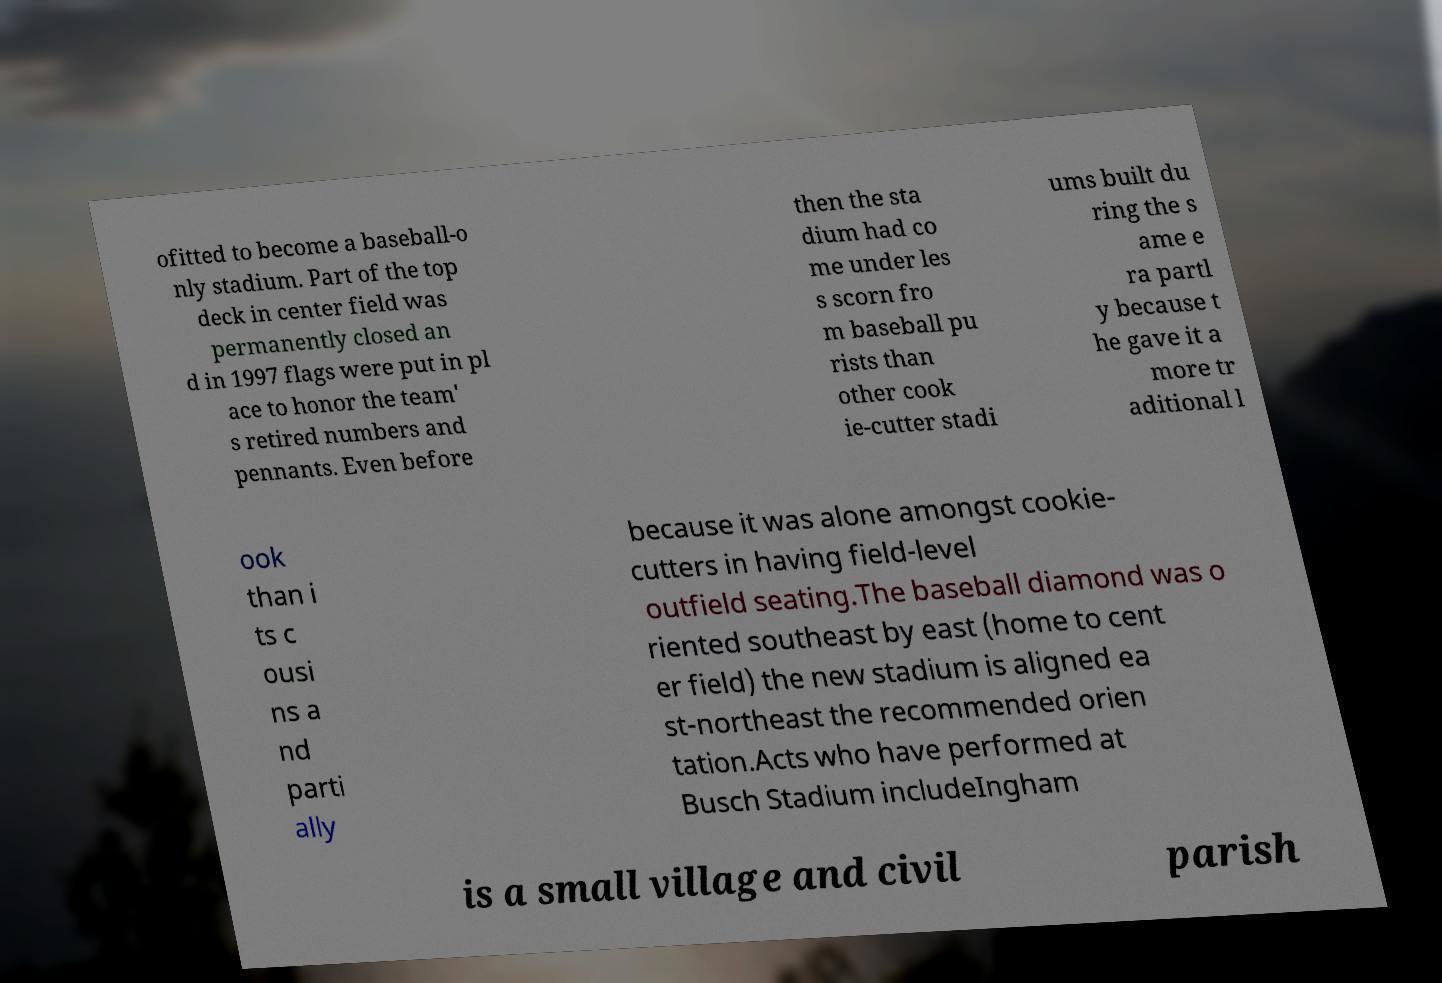What messages or text are displayed in this image? I need them in a readable, typed format. ofitted to become a baseball-o nly stadium. Part of the top deck in center field was permanently closed an d in 1997 flags were put in pl ace to honor the team' s retired numbers and pennants. Even before then the sta dium had co me under les s scorn fro m baseball pu rists than other cook ie-cutter stadi ums built du ring the s ame e ra partl y because t he gave it a more tr aditional l ook than i ts c ousi ns a nd parti ally because it was alone amongst cookie- cutters in having field-level outfield seating.The baseball diamond was o riented southeast by east (home to cent er field) the new stadium is aligned ea st-northeast the recommended orien tation.Acts who have performed at Busch Stadium includeIngham is a small village and civil parish 